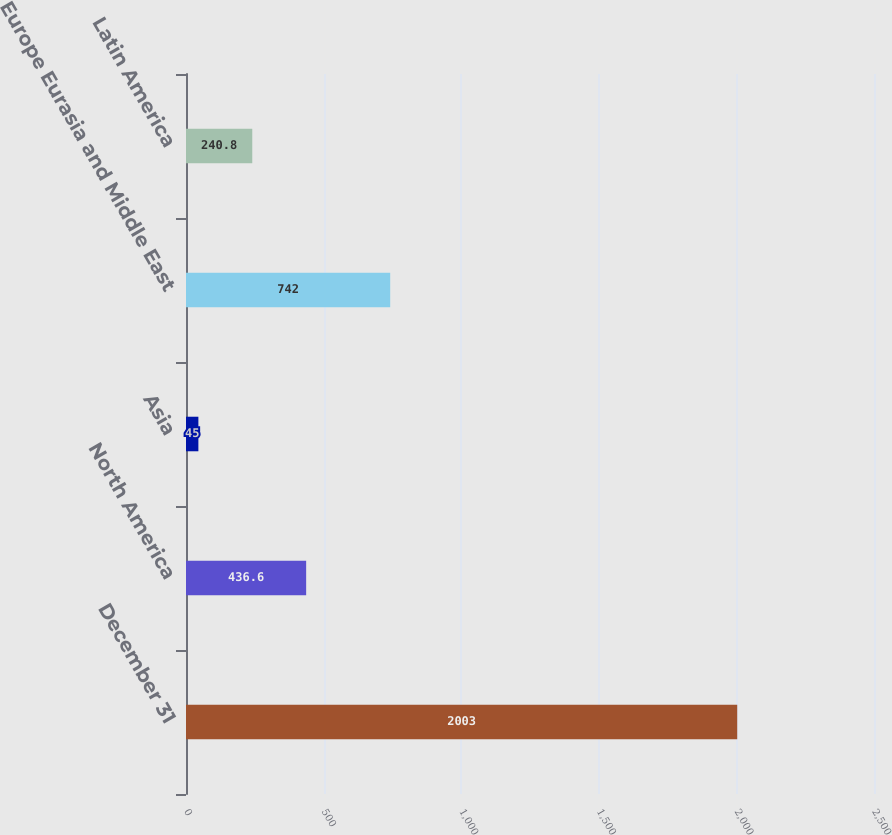Convert chart to OTSL. <chart><loc_0><loc_0><loc_500><loc_500><bar_chart><fcel>December 31<fcel>North America<fcel>Asia<fcel>Europe Eurasia and Middle East<fcel>Latin America<nl><fcel>2003<fcel>436.6<fcel>45<fcel>742<fcel>240.8<nl></chart> 